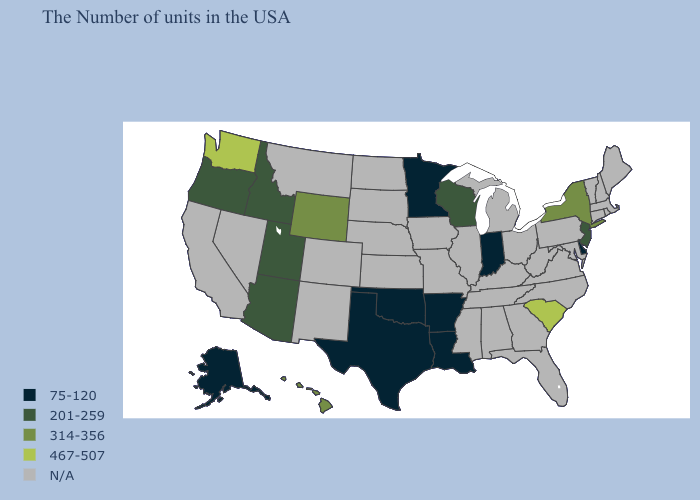What is the value of Nevada?
Write a very short answer. N/A. Name the states that have a value in the range N/A?
Write a very short answer. Maine, Massachusetts, Rhode Island, New Hampshire, Vermont, Connecticut, Maryland, Pennsylvania, Virginia, North Carolina, West Virginia, Ohio, Florida, Georgia, Michigan, Kentucky, Alabama, Tennessee, Illinois, Mississippi, Missouri, Iowa, Kansas, Nebraska, South Dakota, North Dakota, Colorado, New Mexico, Montana, Nevada, California. Name the states that have a value in the range 467-507?
Answer briefly. South Carolina, Washington. Among the states that border Montana , which have the highest value?
Write a very short answer. Wyoming. Which states hav the highest value in the MidWest?
Answer briefly. Wisconsin. Name the states that have a value in the range 201-259?
Keep it brief. New Jersey, Wisconsin, Utah, Arizona, Idaho, Oregon. Which states have the lowest value in the South?
Write a very short answer. Delaware, Louisiana, Arkansas, Oklahoma, Texas. What is the value of South Carolina?
Write a very short answer. 467-507. What is the value of Massachusetts?
Be succinct. N/A. Name the states that have a value in the range 201-259?
Short answer required. New Jersey, Wisconsin, Utah, Arizona, Idaho, Oregon. What is the value of Minnesota?
Give a very brief answer. 75-120. Name the states that have a value in the range 201-259?
Give a very brief answer. New Jersey, Wisconsin, Utah, Arizona, Idaho, Oregon. Among the states that border Kentucky , which have the highest value?
Give a very brief answer. Indiana. What is the value of South Carolina?
Short answer required. 467-507. Name the states that have a value in the range N/A?
Be succinct. Maine, Massachusetts, Rhode Island, New Hampshire, Vermont, Connecticut, Maryland, Pennsylvania, Virginia, North Carolina, West Virginia, Ohio, Florida, Georgia, Michigan, Kentucky, Alabama, Tennessee, Illinois, Mississippi, Missouri, Iowa, Kansas, Nebraska, South Dakota, North Dakota, Colorado, New Mexico, Montana, Nevada, California. 